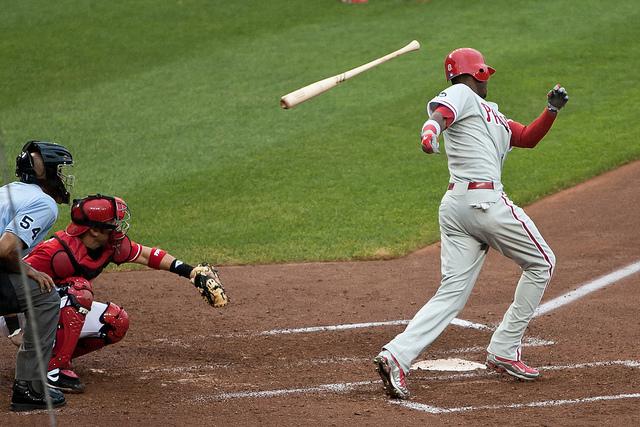What team does he play for?
Short answer required. Phillies. Is the bat still in this batter's hands?
Short answer required. No. What color is his helmet?
Quick response, please. Red. What has the player to the right just done?
Answer briefly. Hit ball. Where is the batter?
Write a very short answer. Running. What happens if the hitter misses the ball?
Concise answer only. Strike. 